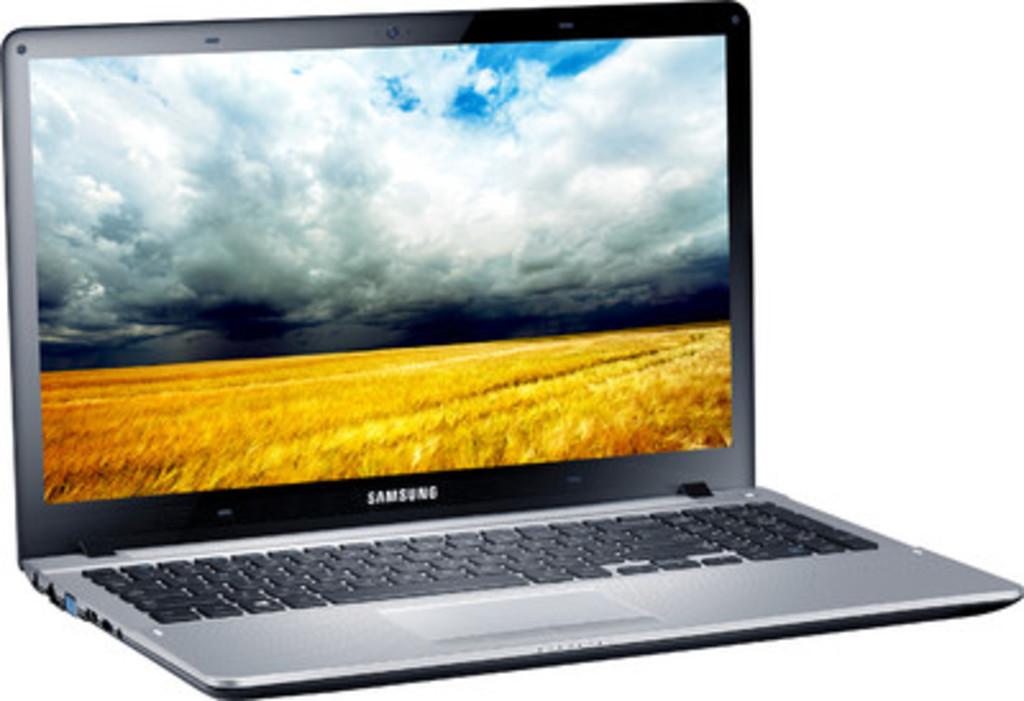What brand of laptop?
Provide a succinct answer. Samsung. 